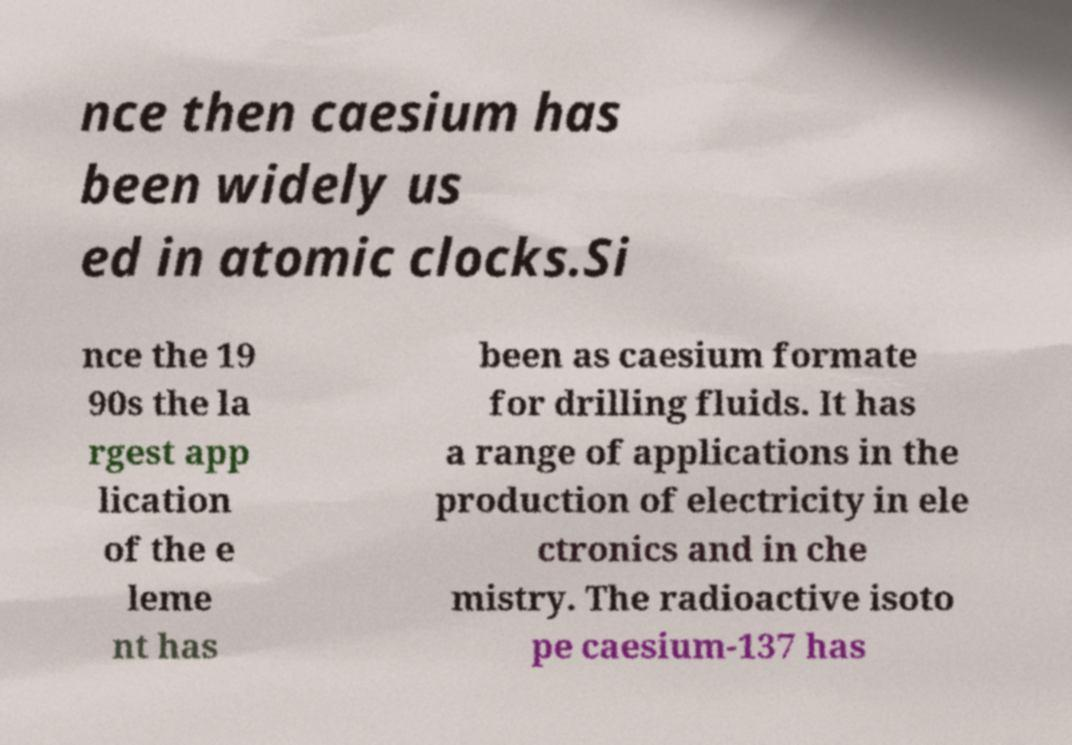What messages or text are displayed in this image? I need them in a readable, typed format. nce then caesium has been widely us ed in atomic clocks.Si nce the 19 90s the la rgest app lication of the e leme nt has been as caesium formate for drilling fluids. It has a range of applications in the production of electricity in ele ctronics and in che mistry. The radioactive isoto pe caesium-137 has 